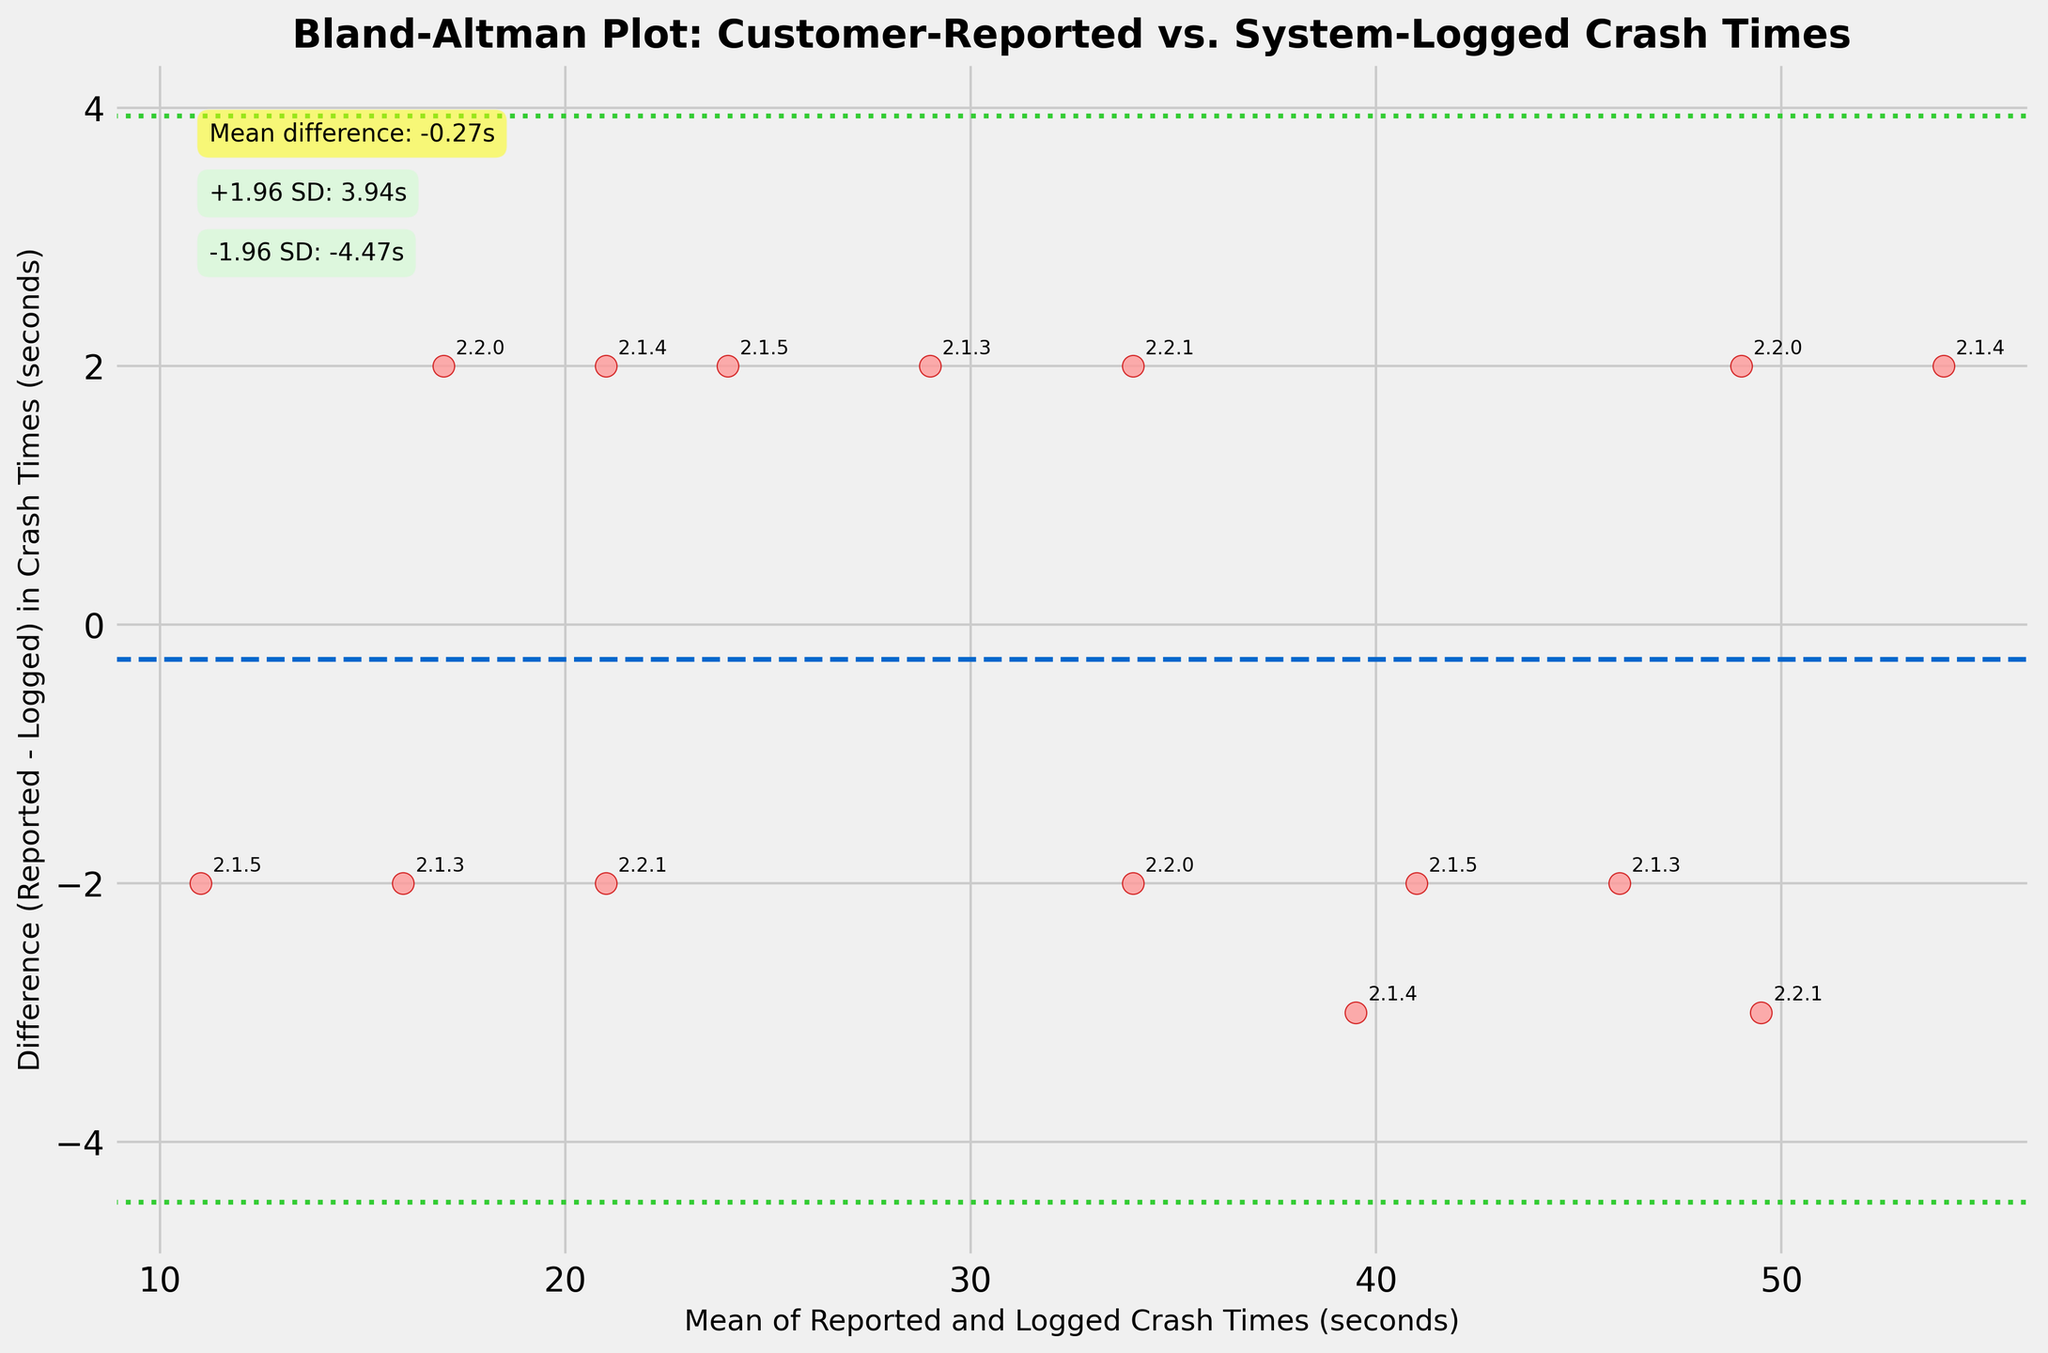What is the title of the plot? The title is located at the top of the figure in bold and large font size, indicating the purpose of the plot.
Answer: Bland-Altman Plot: Customer-Reported vs. System-Logged Crash Times What do the x-axis and y-axis represent? The x-axis represents the "Mean of Reported and Logged Crash Times (seconds)", while the y-axis represents the "Difference (Reported - Logged) in Crash Times (seconds)". These labels can be found along the respective axes.
Answer: Mean of Reported and Logged Crash Times (seconds), Difference (Reported - Logged) in Crash Times (seconds) How many data points are shown in the plot? By counting each scatter point shown in the figure, we determine the number of data points.
Answer: 15 What is the mean difference between the reported and logged crash times? The mean difference line is indicated with a dashed line and annotated on the plot. The annotation provides the exact value of the mean difference.
Answer: 0.33s What app version is represented by the data point nearest to the point where the mean difference intersects the x-axis? A closer look at the scatter point at the intersection of the mean difference line with the x-axis shows the annotated app version value.
Answer: 2.2.0 What are the upper and lower limits of agreement? The limits of agreement are the lines placed 1.96 standard deviations (SD) above and below the mean difference, both values are annotated nearby.
Answer: +1.96 SD: 7.65s, -1.96 SD: -6.99s Which app version has the highest difference in crash times? By observing and comparing the y-values of the scatter points, the data point with the highest y-value corresponds to the app version with the highest difference.
Answer: 2.1.4 What is the approximate standard deviation of the differences in crash times? The upper and lower limits of agreement are calculated as mean difference ± 1.96 SD. From these annotations, rearrange the equation to solve for SD. Upper limit = 0.33s + 1.96 SD, hence SD ≈ (7.65s - 0.33s) / 1.96 ≈ 3.74s.
Answer: 3.74s Are there any app versions where the difference in crash times is consistently positive or negative? Examine the scatter points for each app version and see if all points for an app version are consistently above (positive) or below (negative) the mean difference line.
Answer: No, differences vary for each app version 